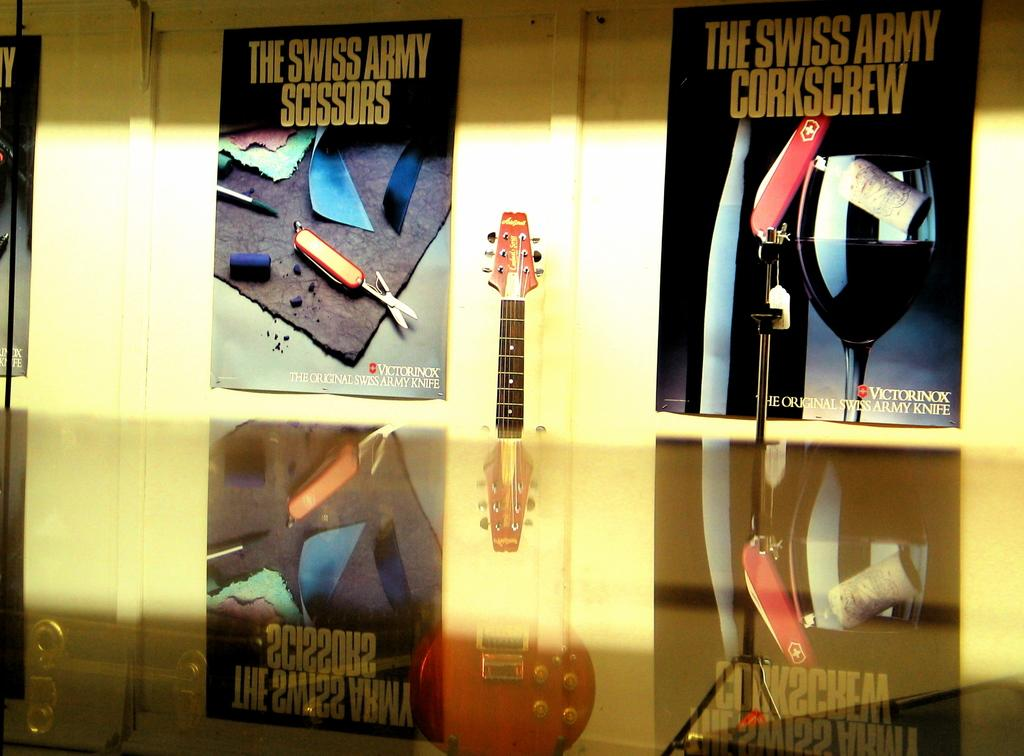Provide a one-sentence caption for the provided image. On either side of an electric guitar are two posters advertising Swiss Army knives. 